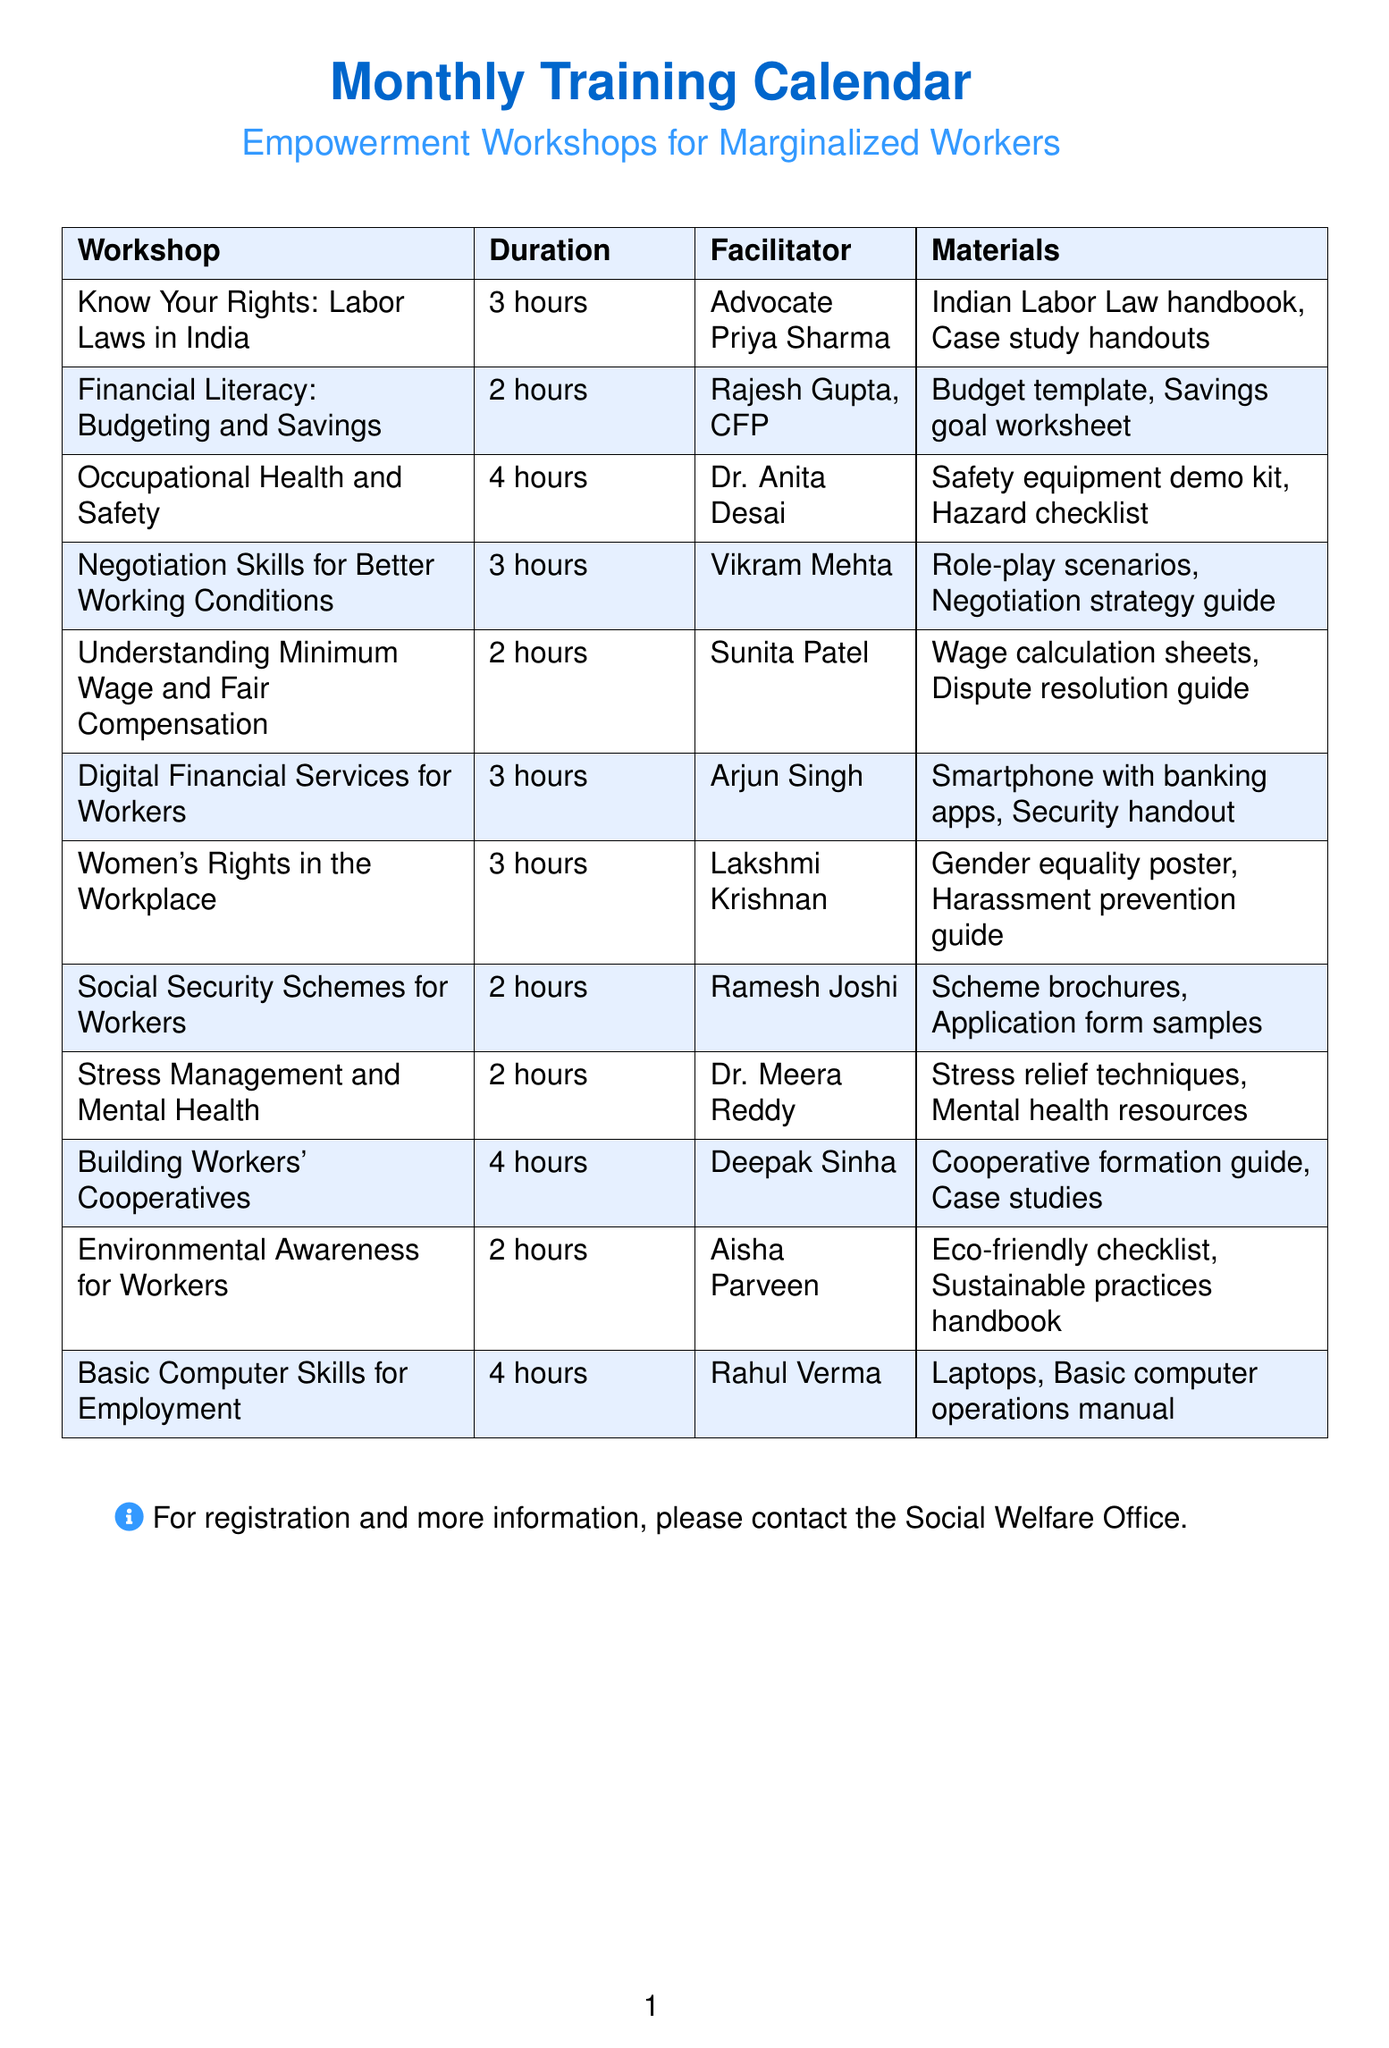what is the duration of the workshop titled "Know Your Rights: Labor Laws in India"? The duration is specified in the table under the duration column for the workshop titled "Know Your Rights: Labor Laws in India".
Answer: 3 hours who is the facilitator for the "Digital Financial Services for Workers" workshop? The facilitator is listed in the table next to the workshop title "Digital Financial Services for Workers".
Answer: Arjun Singh what materials are provided for the "Women's Rights in the Workplace" workshop? The materials are detailed in the table under the materials column corresponding to the "Women's Rights in the Workplace" workshop.
Answer: Gender equality in workplace poster, Sexual harassment prevention guide how many workshops are conducted for a duration of 2 hours? This requires counting the workshops listed in the document with a duration of 2 hours.
Answer: 4 workshops which workshop has the longest duration? By comparing the durations listed in the table, the longest duration can be identified.
Answer: Occupational Health and Safety, Basic Computer Skills for Employment (both 4 hours) who is the expert leading the "Negotiation Skills for Better Working Conditions"? The expert's name is mentioned in the facilitator column for the "Negotiation Skills for Better Working Conditions" workshop.
Answer: Vikram Mehta what is the focus of the "Occupational Health and Safety" workshop? The focus is described in the workshop's description within the document.
Answer: Identifying workplace hazards and promoting safe practices how many facilitators have the title "Doctor"? This question asks for identification of facilitators with the title "Doctor" from the list.
Answer: 2 facilitators 